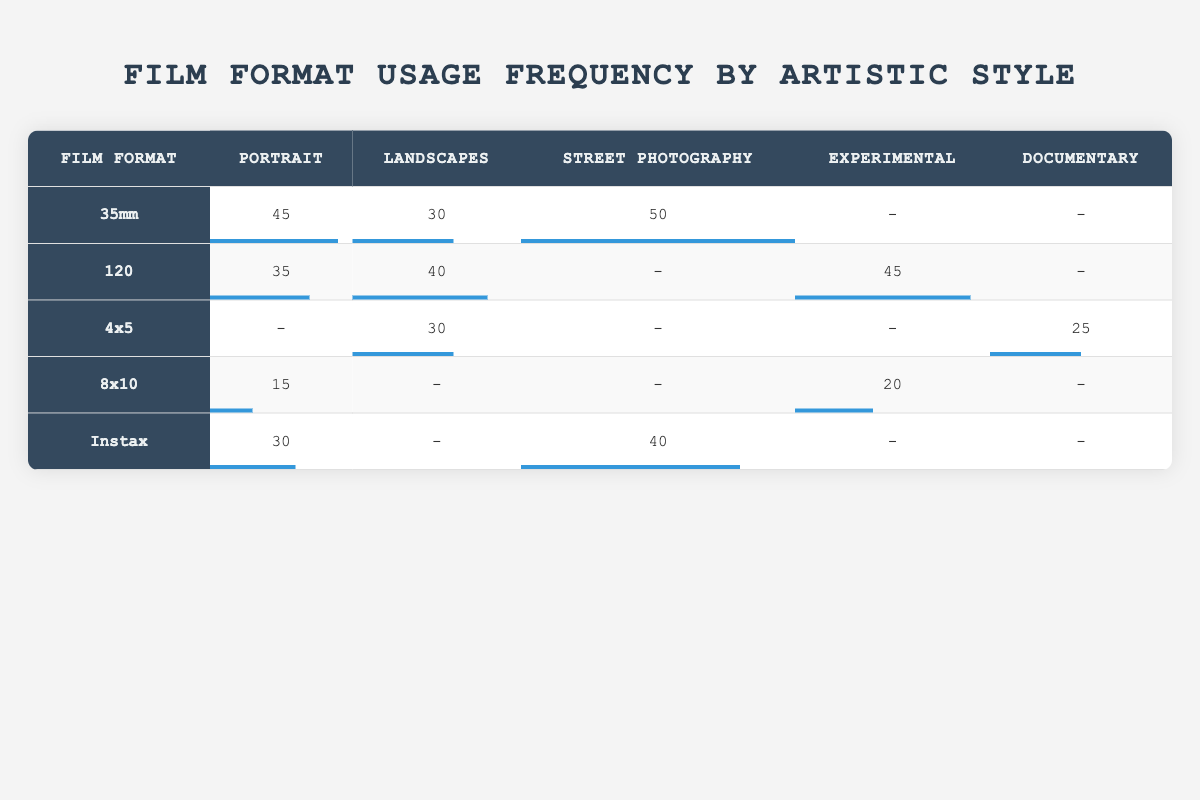What is the highest frequency of film format used for Street Photography? In the table, the frequency for Street Photography is listed for various film formats. Looking at the row for each film format, 35mm has a frequency of 50, Instax has a frequency of 40, and all others have lower values. Therefore, 35mm is the highest.
Answer: 50 Which film format is most commonly used for Portrait photography? By examining the frequencies under the Portrait category, 35mm has a frequency of 45, 120 has 35, Instax has 30, 8x10 has 15, and 4x5 is not used. 35mm has the highest number.
Answer: 35mm What is the average frequency of film formats used for Experimental photography? The frequencies for Experimental photography are 45 (120), 20 (8x10), and 0 for others. To find the average, sum these values: 45 + 20 + 0 = 65. There are three data points, so 65/3 = approximately 21.67.
Answer: 21.67 Is the frequency of 8x10 format used for Documentary photography more than that of 4x5 format? The frequency of 8x10 for Documentary photography is 0, and for 4x5, it is 25. Since 0 is less than 25, the statement is false.
Answer: No What is the difference in frequency for Landscapes between 120 and 4x5 film formats? The frequency for Landscapes with 120 is 40, while 4x5 has 30. To find the difference, subtract 30 from 40, resulting in 10.
Answer: 10 Which artistic style has the least use of 8x10 film format? Checking the table, 8x10 has a frequency of 15 for Portrait, 0 for Landscapes, 0 for Street Photography, 20 for Experimental, and 0 for Documentary. Therefore, 8x10 is least used for Landscapes, Street Photography, and Documentary, all with 0.
Answer: Landscapes, Street Photography, Documentary Which film format has the lowest overall frequency of use across all artistic styles? To determine this, we sum the frequencies for each format: 35mm (125), 120 (120), 4x5 (55), 8x10 (35), and Instax (70). 8x10 has the lowest total frequency.
Answer: 8x10 Does the usage frequency for 120 film format exceed that of Instax for Documentary photography? The frequency for 120 in Documentary is 0 and for Instax it is also 0. Since neither exceeds the other, this statement is true.
Answer: Yes 